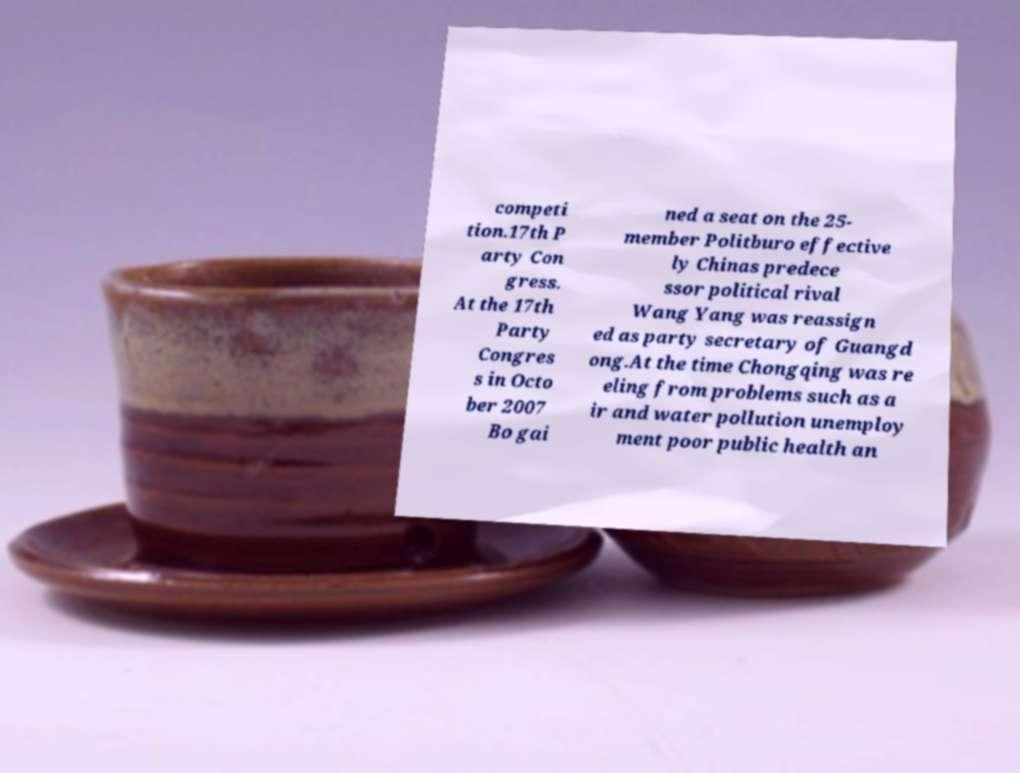Can you read and provide the text displayed in the image?This photo seems to have some interesting text. Can you extract and type it out for me? competi tion.17th P arty Con gress. At the 17th Party Congres s in Octo ber 2007 Bo gai ned a seat on the 25- member Politburo effective ly Chinas predece ssor political rival Wang Yang was reassign ed as party secretary of Guangd ong.At the time Chongqing was re eling from problems such as a ir and water pollution unemploy ment poor public health an 